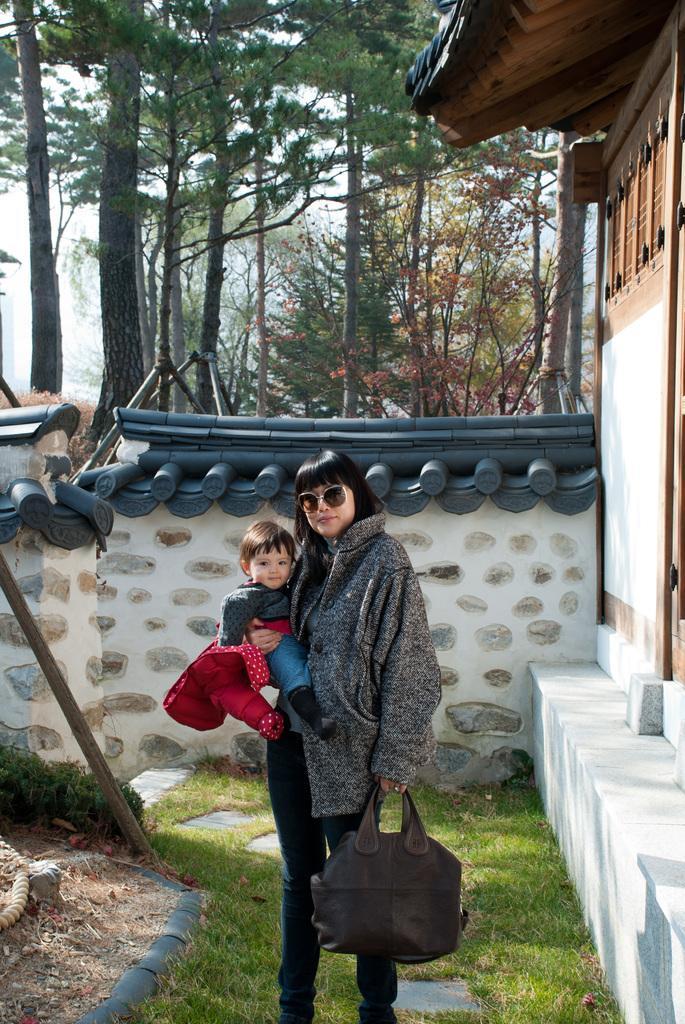Could you give a brief overview of what you see in this image? In this image, in the middle there is a woman she is standing and she is holding a bag which is in black color, she is holding a kid in her right hand, in the right side there is a white color wall and there are some brown color doors, in the background there is a white color wall and there are some green color trees. 